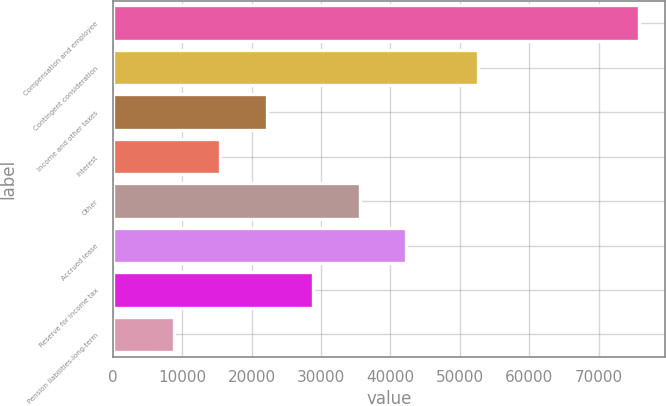<chart> <loc_0><loc_0><loc_500><loc_500><bar_chart><fcel>Compensation and employee<fcel>Contingent consideration<fcel>Income and other taxes<fcel>Interest<fcel>Other<fcel>Accrued lease<fcel>Reserve for income tax<fcel>Pension liabilities-long-term<nl><fcel>75772<fcel>52562<fcel>22159.2<fcel>15457.6<fcel>35562.4<fcel>42264<fcel>28860.8<fcel>8756<nl></chart> 